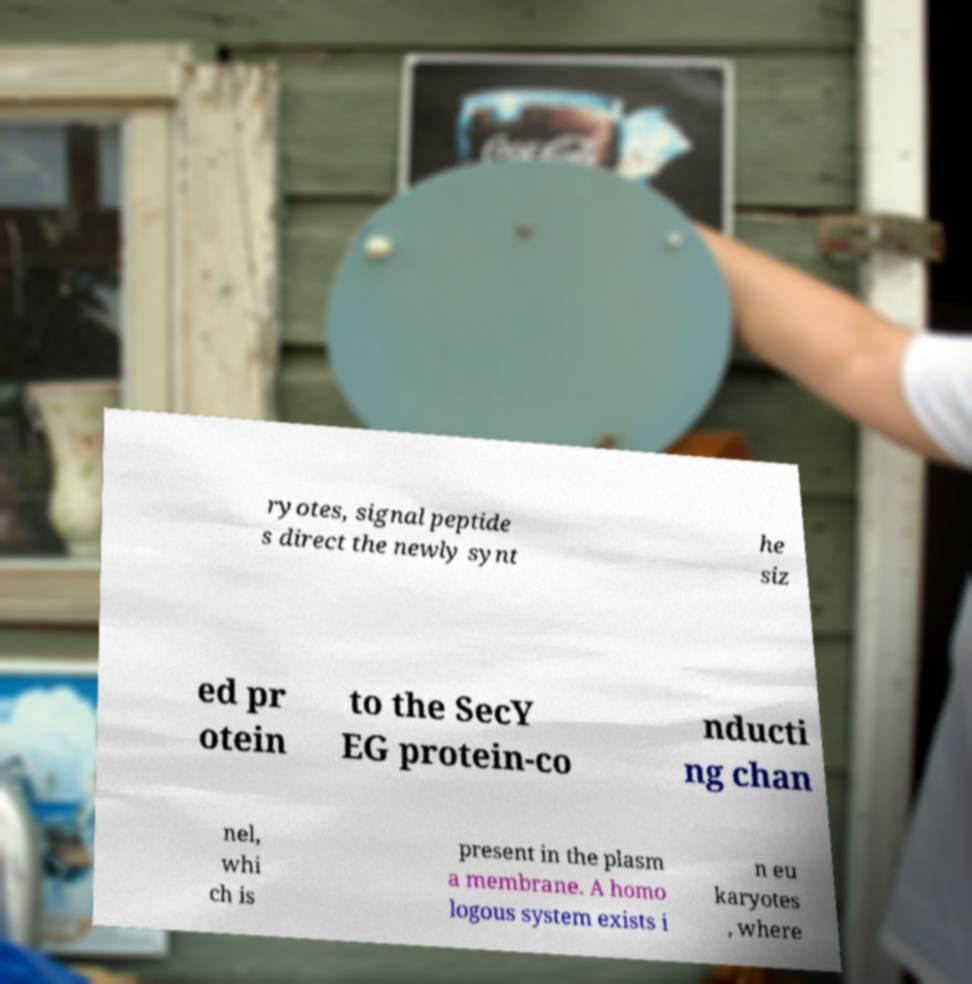Could you extract and type out the text from this image? ryotes, signal peptide s direct the newly synt he siz ed pr otein to the SecY EG protein-co nducti ng chan nel, whi ch is present in the plasm a membrane. A homo logous system exists i n eu karyotes , where 